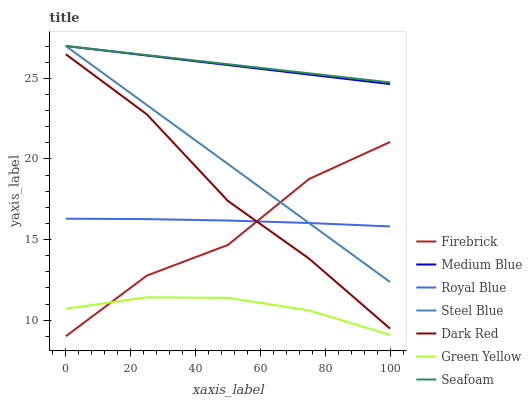Does Firebrick have the minimum area under the curve?
Answer yes or no. No. Does Firebrick have the maximum area under the curve?
Answer yes or no. No. Is Firebrick the smoothest?
Answer yes or no. No. Is Medium Blue the roughest?
Answer yes or no. No. Does Medium Blue have the lowest value?
Answer yes or no. No. Does Firebrick have the highest value?
Answer yes or no. No. Is Dark Red less than Steel Blue?
Answer yes or no. Yes. Is Steel Blue greater than Dark Red?
Answer yes or no. Yes. Does Dark Red intersect Steel Blue?
Answer yes or no. No. 